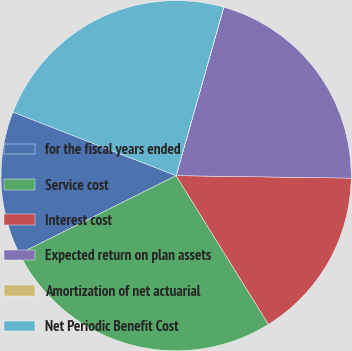Convert chart to OTSL. <chart><loc_0><loc_0><loc_500><loc_500><pie_chart><fcel>for the fiscal years ended<fcel>Service cost<fcel>Interest cost<fcel>Expected return on plan assets<fcel>Amortization of net actuarial<fcel>Net Periodic Benefit Cost<nl><fcel>13.27%<fcel>26.49%<fcel>15.93%<fcel>20.83%<fcel>0.02%<fcel>23.47%<nl></chart> 